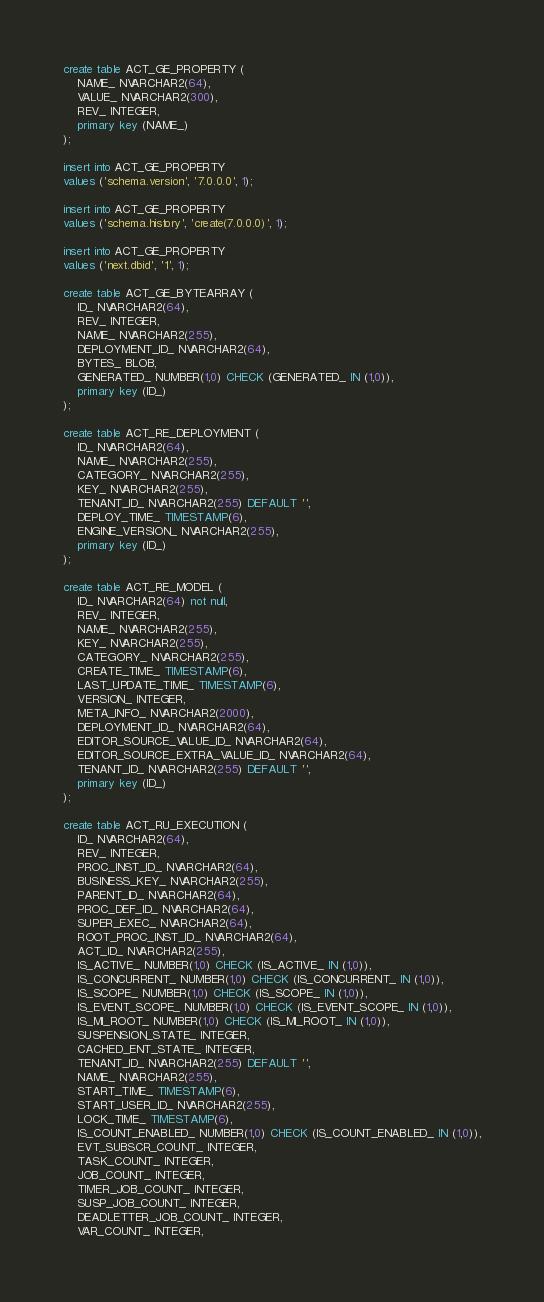<code> <loc_0><loc_0><loc_500><loc_500><_SQL_>create table ACT_GE_PROPERTY (
    NAME_ NVARCHAR2(64),
    VALUE_ NVARCHAR2(300),
    REV_ INTEGER,
    primary key (NAME_)
);

insert into ACT_GE_PROPERTY
values ('schema.version', '7.0.0.0', 1);

insert into ACT_GE_PROPERTY
values ('schema.history', 'create(7.0.0.0)', 1);

insert into ACT_GE_PROPERTY
values ('next.dbid', '1', 1);

create table ACT_GE_BYTEARRAY (
    ID_ NVARCHAR2(64),
    REV_ INTEGER,
    NAME_ NVARCHAR2(255),
    DEPLOYMENT_ID_ NVARCHAR2(64),
    BYTES_ BLOB,
    GENERATED_ NUMBER(1,0) CHECK (GENERATED_ IN (1,0)),
    primary key (ID_)
);

create table ACT_RE_DEPLOYMENT (
    ID_ NVARCHAR2(64),
    NAME_ NVARCHAR2(255),
    CATEGORY_ NVARCHAR2(255),
    KEY_ NVARCHAR2(255),
    TENANT_ID_ NVARCHAR2(255) DEFAULT '',
    DEPLOY_TIME_ TIMESTAMP(6),
    ENGINE_VERSION_ NVARCHAR2(255),
    primary key (ID_)
);

create table ACT_RE_MODEL (
    ID_ NVARCHAR2(64) not null,
    REV_ INTEGER,
    NAME_ NVARCHAR2(255),
    KEY_ NVARCHAR2(255),
    CATEGORY_ NVARCHAR2(255),
    CREATE_TIME_ TIMESTAMP(6),
    LAST_UPDATE_TIME_ TIMESTAMP(6),
    VERSION_ INTEGER,
    META_INFO_ NVARCHAR2(2000),
    DEPLOYMENT_ID_ NVARCHAR2(64),
    EDITOR_SOURCE_VALUE_ID_ NVARCHAR2(64),
    EDITOR_SOURCE_EXTRA_VALUE_ID_ NVARCHAR2(64),
    TENANT_ID_ NVARCHAR2(255) DEFAULT '',
    primary key (ID_)
);

create table ACT_RU_EXECUTION (
    ID_ NVARCHAR2(64),
    REV_ INTEGER,
    PROC_INST_ID_ NVARCHAR2(64),
    BUSINESS_KEY_ NVARCHAR2(255),
    PARENT_ID_ NVARCHAR2(64),
    PROC_DEF_ID_ NVARCHAR2(64),
    SUPER_EXEC_ NVARCHAR2(64),
    ROOT_PROC_INST_ID_ NVARCHAR2(64),
    ACT_ID_ NVARCHAR2(255),
    IS_ACTIVE_ NUMBER(1,0) CHECK (IS_ACTIVE_ IN (1,0)),
    IS_CONCURRENT_ NUMBER(1,0) CHECK (IS_CONCURRENT_ IN (1,0)),
    IS_SCOPE_ NUMBER(1,0) CHECK (IS_SCOPE_ IN (1,0)),
    IS_EVENT_SCOPE_ NUMBER(1,0) CHECK (IS_EVENT_SCOPE_ IN (1,0)),
    IS_MI_ROOT_ NUMBER(1,0) CHECK (IS_MI_ROOT_ IN (1,0)),
    SUSPENSION_STATE_ INTEGER,
    CACHED_ENT_STATE_ INTEGER,
    TENANT_ID_ NVARCHAR2(255) DEFAULT '',
    NAME_ NVARCHAR2(255),
    START_TIME_ TIMESTAMP(6),
    START_USER_ID_ NVARCHAR2(255),
    LOCK_TIME_ TIMESTAMP(6),
    IS_COUNT_ENABLED_ NUMBER(1,0) CHECK (IS_COUNT_ENABLED_ IN (1,0)),
    EVT_SUBSCR_COUNT_ INTEGER, 
    TASK_COUNT_ INTEGER, 
    JOB_COUNT_ INTEGER, 
    TIMER_JOB_COUNT_ INTEGER,
    SUSP_JOB_COUNT_ INTEGER,
    DEADLETTER_JOB_COUNT_ INTEGER,
    VAR_COUNT_ INTEGER, </code> 